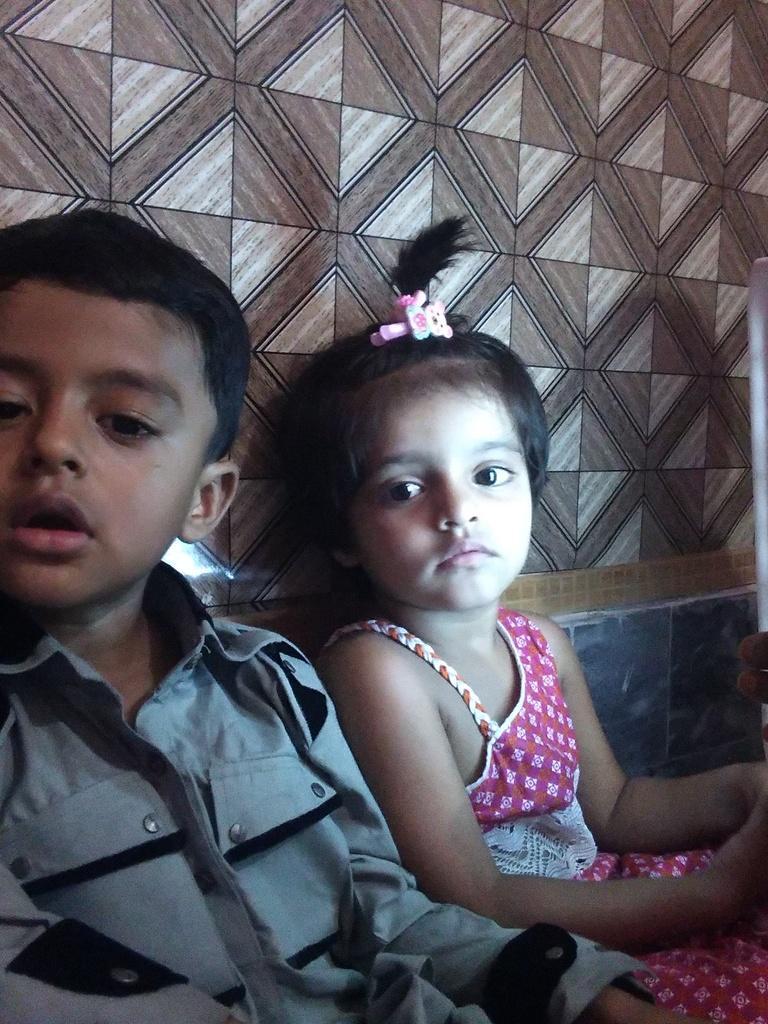Please provide a concise description of this image. In this image there are two kids sitting near a wall. 